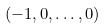Convert formula to latex. <formula><loc_0><loc_0><loc_500><loc_500>( - 1 , 0 , \dots , 0 )</formula> 